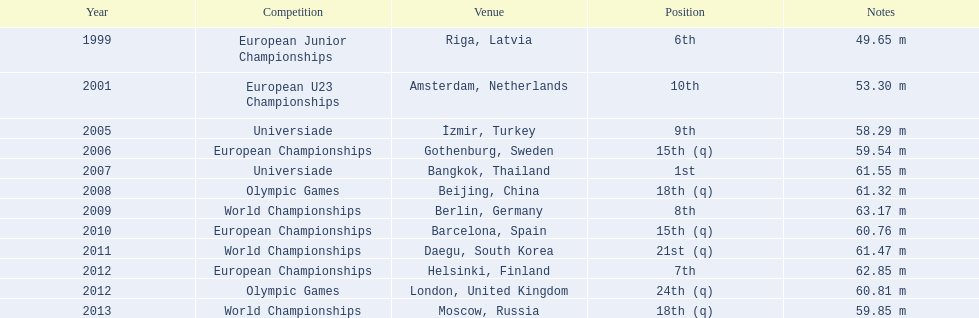In which events has gerhard mayer taken part since 1999? European Junior Championships, European U23 Championships, Universiade, European Championships, Universiade, Olympic Games, World Championships, European Championships, World Championships, European Championships, Olympic Games, World Championships. Out of these, where did he achieve at least a 60-meter throw? Universiade, Olympic Games, World Championships, European Championships, World Championships, European Championships, Olympic Games. I'm looking to parse the entire table for insights. Could you assist me with that? {'header': ['Year', 'Competition', 'Venue', 'Position', 'Notes'], 'rows': [['1999', 'European Junior Championships', 'Riga, Latvia', '6th', '49.65 m'], ['2001', 'European U23 Championships', 'Amsterdam, Netherlands', '10th', '53.30 m'], ['2005', 'Universiade', 'İzmir, Turkey', '9th', '58.29 m'], ['2006', 'European Championships', 'Gothenburg, Sweden', '15th (q)', '59.54 m'], ['2007', 'Universiade', 'Bangkok, Thailand', '1st', '61.55 m'], ['2008', 'Olympic Games', 'Beijing, China', '18th (q)', '61.32 m'], ['2009', 'World Championships', 'Berlin, Germany', '8th', '63.17 m'], ['2010', 'European Championships', 'Barcelona, Spain', '15th (q)', '60.76 m'], ['2011', 'World Championships', 'Daegu, South Korea', '21st (q)', '61.47 m'], ['2012', 'European Championships', 'Helsinki, Finland', '7th', '62.85 m'], ['2012', 'Olympic Games', 'London, United Kingdom', '24th (q)', '60.81 m'], ['2013', 'World Championships', 'Moscow, Russia', '18th (q)', '59.85 m']]} From these attempts, which had the furthest distance? 63.17 m. 